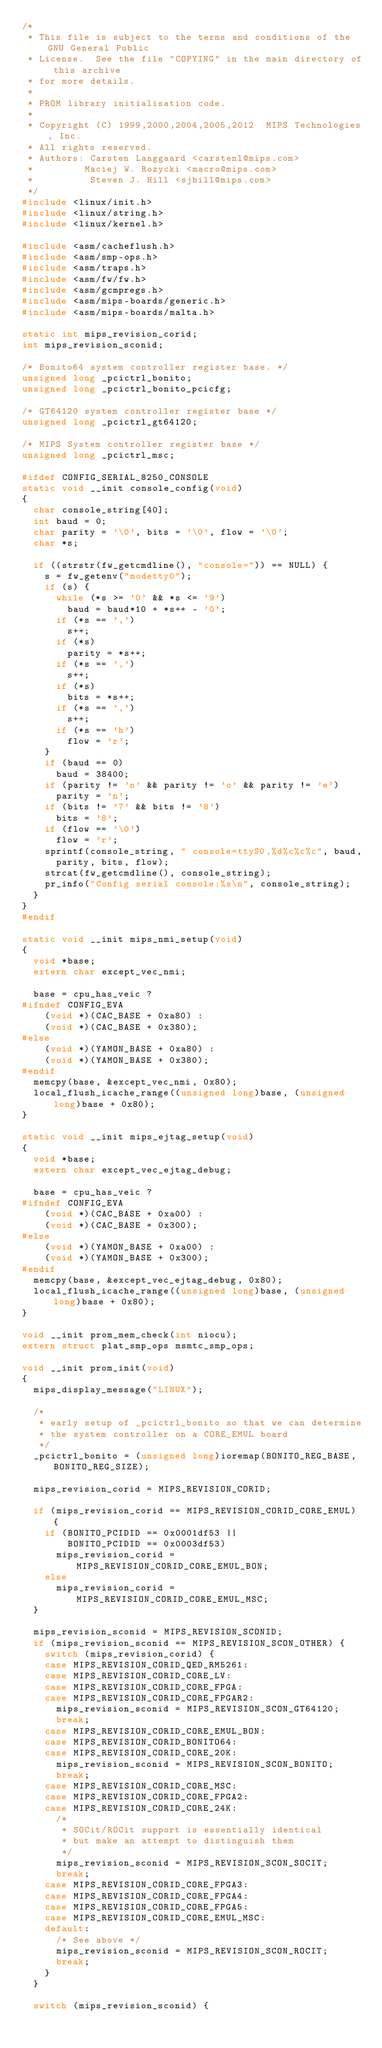<code> <loc_0><loc_0><loc_500><loc_500><_C_>/*
 * This file is subject to the terms and conditions of the GNU General Public
 * License.  See the file "COPYING" in the main directory of this archive
 * for more details.
 *
 * PROM library initialisation code.
 *
 * Copyright (C) 1999,2000,2004,2005,2012  MIPS Technologies, Inc.
 * All rights reserved.
 * Authors: Carsten Langgaard <carstenl@mips.com>
 *         Maciej W. Rozycki <macro@mips.com>
 *          Steven J. Hill <sjhill@mips.com>
 */
#include <linux/init.h>
#include <linux/string.h>
#include <linux/kernel.h>

#include <asm/cacheflush.h>
#include <asm/smp-ops.h>
#include <asm/traps.h>
#include <asm/fw/fw.h>
#include <asm/gcmpregs.h>
#include <asm/mips-boards/generic.h>
#include <asm/mips-boards/malta.h>

static int mips_revision_corid;
int mips_revision_sconid;

/* Bonito64 system controller register base. */
unsigned long _pcictrl_bonito;
unsigned long _pcictrl_bonito_pcicfg;

/* GT64120 system controller register base */
unsigned long _pcictrl_gt64120;

/* MIPS System controller register base */
unsigned long _pcictrl_msc;

#ifdef CONFIG_SERIAL_8250_CONSOLE
static void __init console_config(void)
{
	char console_string[40];
	int baud = 0;
	char parity = '\0', bits = '\0', flow = '\0';
	char *s;

	if ((strstr(fw_getcmdline(), "console=")) == NULL) {
		s = fw_getenv("modetty0");
		if (s) {
			while (*s >= '0' && *s <= '9')
				baud = baud*10 + *s++ - '0';
			if (*s == ',')
				s++;
			if (*s)
				parity = *s++;
			if (*s == ',')
				s++;
			if (*s)
				bits = *s++;
			if (*s == ',')
				s++;
			if (*s == 'h')
				flow = 'r';
		}
		if (baud == 0)
			baud = 38400;
		if (parity != 'n' && parity != 'o' && parity != 'e')
			parity = 'n';
		if (bits != '7' && bits != '8')
			bits = '8';
		if (flow == '\0')
			flow = 'r';
		sprintf(console_string, " console=ttyS0,%d%c%c%c", baud,
			parity, bits, flow);
		strcat(fw_getcmdline(), console_string);
		pr_info("Config serial console:%s\n", console_string);
	}
}
#endif

static void __init mips_nmi_setup(void)
{
	void *base;
	extern char except_vec_nmi;

	base = cpu_has_veic ?
#ifndef CONFIG_EVA
		(void *)(CAC_BASE + 0xa80) :
		(void *)(CAC_BASE + 0x380);
#else
		(void *)(YAMON_BASE + 0xa80) :
		(void *)(YAMON_BASE + 0x380);
#endif
	memcpy(base, &except_vec_nmi, 0x80);
	local_flush_icache_range((unsigned long)base, (unsigned long)base + 0x80);
}

static void __init mips_ejtag_setup(void)
{
	void *base;
	extern char except_vec_ejtag_debug;

	base = cpu_has_veic ?
#ifndef CONFIG_EVA
		(void *)(CAC_BASE + 0xa00) :
		(void *)(CAC_BASE + 0x300);
#else
		(void *)(YAMON_BASE + 0xa00) :
		(void *)(YAMON_BASE + 0x300);
#endif
	memcpy(base, &except_vec_ejtag_debug, 0x80);
	local_flush_icache_range((unsigned long)base, (unsigned long)base + 0x80);
}

void __init prom_mem_check(int niocu);
extern struct plat_smp_ops msmtc_smp_ops;

void __init prom_init(void)
{
	mips_display_message("LINUX");

	/*
	 * early setup of _pcictrl_bonito so that we can determine
	 * the system controller on a CORE_EMUL board
	 */
	_pcictrl_bonito = (unsigned long)ioremap(BONITO_REG_BASE, BONITO_REG_SIZE);

	mips_revision_corid = MIPS_REVISION_CORID;

	if (mips_revision_corid == MIPS_REVISION_CORID_CORE_EMUL) {
		if (BONITO_PCIDID == 0x0001df53 ||
		    BONITO_PCIDID == 0x0003df53)
			mips_revision_corid = MIPS_REVISION_CORID_CORE_EMUL_BON;
		else
			mips_revision_corid = MIPS_REVISION_CORID_CORE_EMUL_MSC;
	}

	mips_revision_sconid = MIPS_REVISION_SCONID;
	if (mips_revision_sconid == MIPS_REVISION_SCON_OTHER) {
		switch (mips_revision_corid) {
		case MIPS_REVISION_CORID_QED_RM5261:
		case MIPS_REVISION_CORID_CORE_LV:
		case MIPS_REVISION_CORID_CORE_FPGA:
		case MIPS_REVISION_CORID_CORE_FPGAR2:
			mips_revision_sconid = MIPS_REVISION_SCON_GT64120;
			break;
		case MIPS_REVISION_CORID_CORE_EMUL_BON:
		case MIPS_REVISION_CORID_BONITO64:
		case MIPS_REVISION_CORID_CORE_20K:
			mips_revision_sconid = MIPS_REVISION_SCON_BONITO;
			break;
		case MIPS_REVISION_CORID_CORE_MSC:
		case MIPS_REVISION_CORID_CORE_FPGA2:
		case MIPS_REVISION_CORID_CORE_24K:
			/*
			 * SOCit/ROCit support is essentially identical
			 * but make an attempt to distinguish them
			 */
			mips_revision_sconid = MIPS_REVISION_SCON_SOCIT;
			break;
		case MIPS_REVISION_CORID_CORE_FPGA3:
		case MIPS_REVISION_CORID_CORE_FPGA4:
		case MIPS_REVISION_CORID_CORE_FPGA5:
		case MIPS_REVISION_CORID_CORE_EMUL_MSC:
		default:
			/* See above */
			mips_revision_sconid = MIPS_REVISION_SCON_ROCIT;
			break;
		}
	}

	switch (mips_revision_sconid) {</code> 